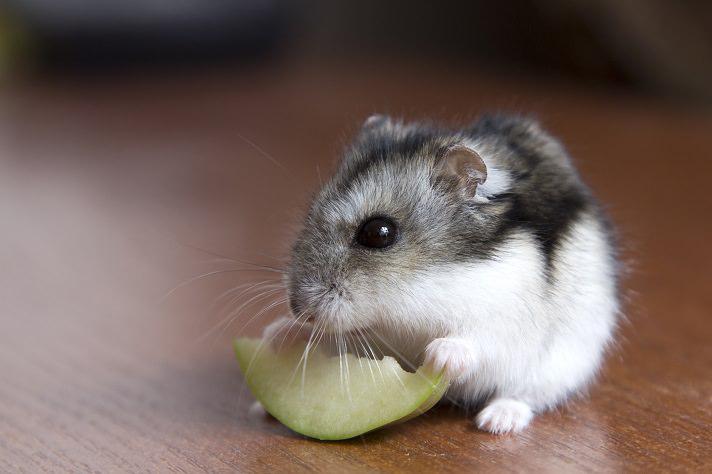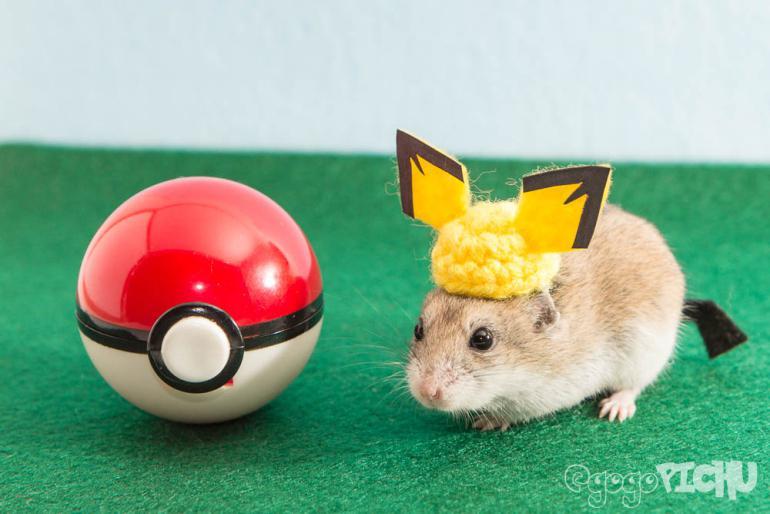The first image is the image on the left, the second image is the image on the right. For the images displayed, is the sentence "The hamsters in each image appear sort of orangish, and the ones pictured by themselves also have some food they are eating." factually correct? Answer yes or no. No. The first image is the image on the left, the second image is the image on the right. For the images displayed, is the sentence "An image shows one hamster on the right of a round object with orange-red coloring." factually correct? Answer yes or no. Yes. 